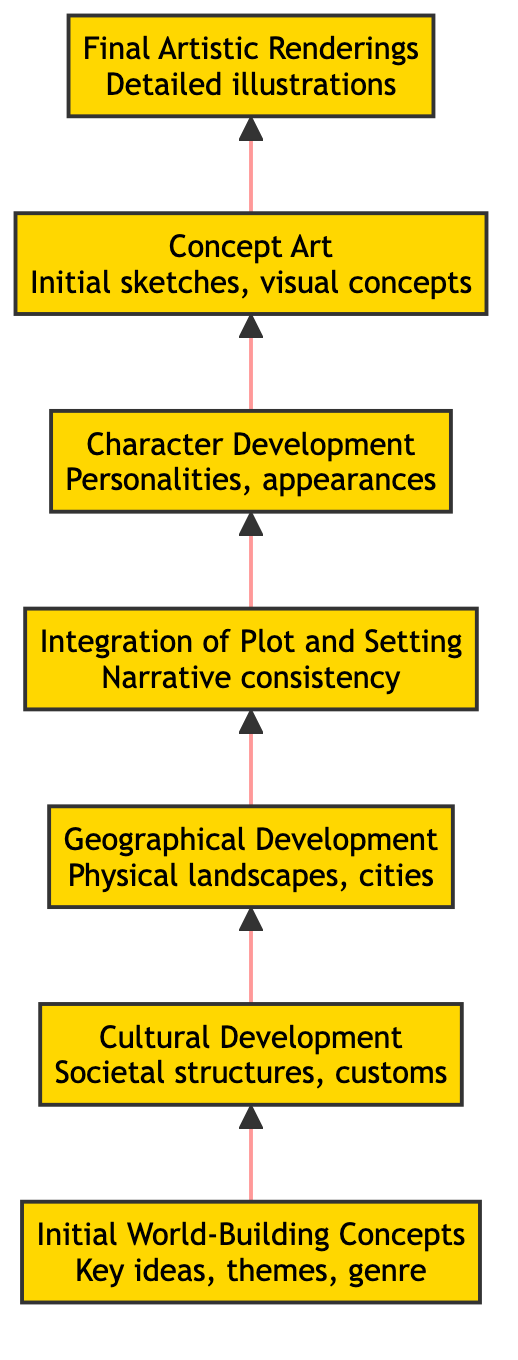What is the top stage in the flowchart? The top stage in the flowchart is indicated by the last element in the upward flow, which is "Final Artistic Renderings."
Answer: Final Artistic Renderings How many stages are in the flowchart? To find the total number of stages, we count each unique element in the flowchart: Initial World-Building Concepts, Cultural Development, Geographical Development, Integration of Plot and Setting, Character Development, Concept Art, and Final Artistic Renderings, totalling 7 stages.
Answer: 7 What precedes 'Concept Art' in the flowchart? By following the flow from the bottom to the top, we see that 'Character Development' is the stage that flows directly into 'Concept Art.'
Answer: Character Development Which stage focuses on societal structures? The stage that discusses societal structures is the second element, 'Cultural Development,' as specified in the description.
Answer: Cultural Development What stage integrates the plot and setting? The stage responsible for integrating the plot and setting is 'Integration of Plot and Setting,' where narrative threads are woven with the developed world.
Answer: Integration of Plot and Setting What is a key aspect of 'Geographical Development'? The key aspect of 'Geographical Development' involves mapping out physical landscapes and significant locations, highlighting its role in shaping the world.
Answer: Physical landscapes Which stage directly follows 'Geographical Development'? The flow indicates that 'Integration of Plot and Setting' directly follows after 'Geographical Development,' as it builds upon the geographical backdrop.
Answer: Integration of Plot and Setting What is one of the examples given for 'Initial World-Building Concepts'? One example indicated for 'Initial World-Building Concepts' is 'Fantasy: Magic-infused realms,' showcasing a clear concept within that genre.
Answer: Fantasy: Magic-infused realms How does 'Character Development' relate to 'Final Artistic Renderings'? 'Character Development' provides distinct characters, which are essential for 'Final Artistic Renderings' as they inform the visuals needed to portray those characters in the graphic novel.
Answer: They are sequential stages 